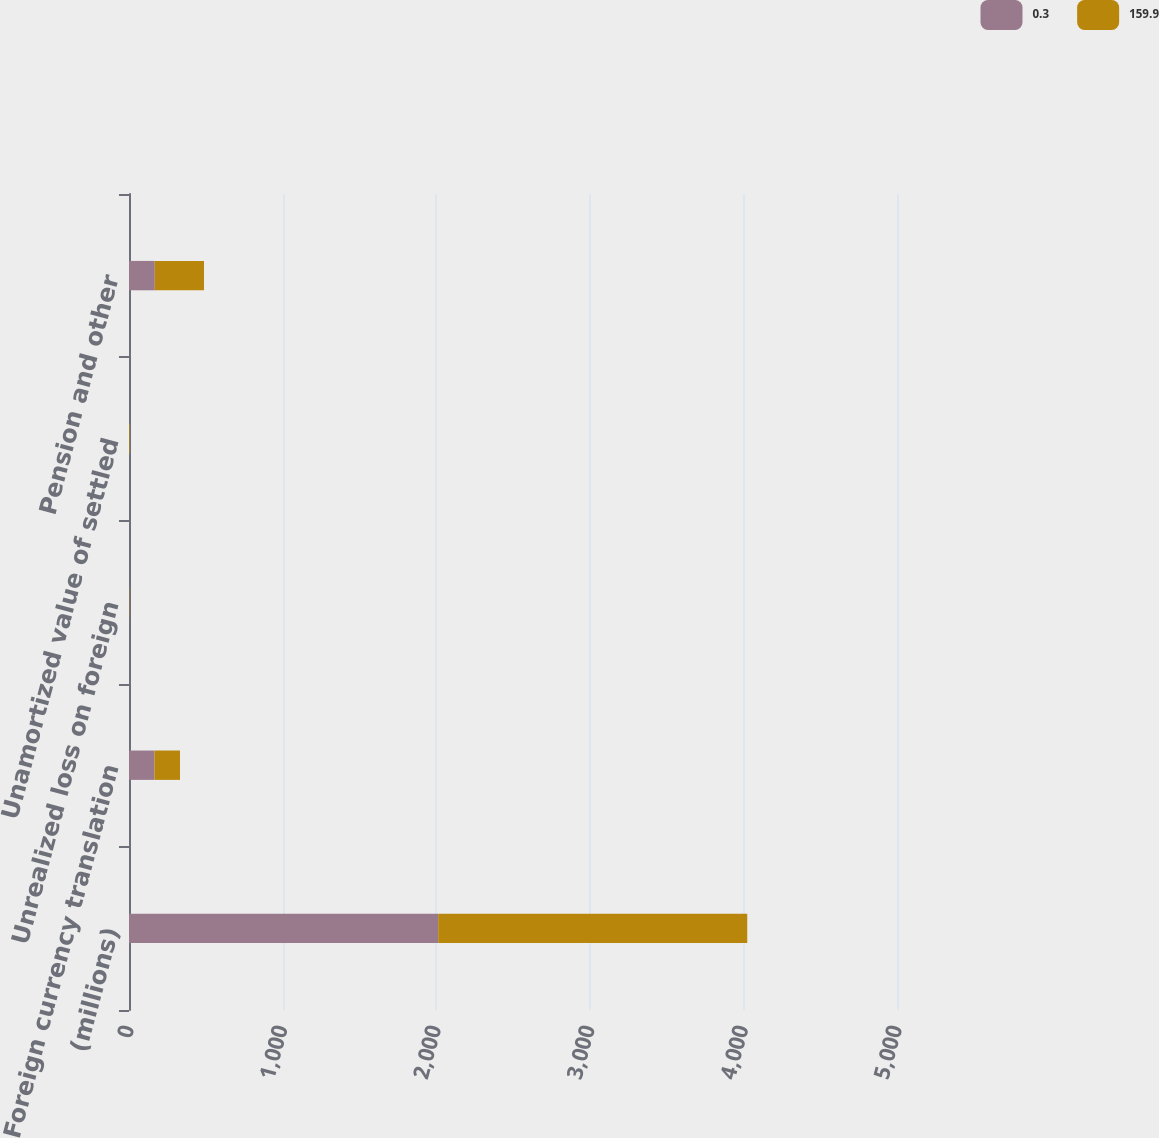<chart> <loc_0><loc_0><loc_500><loc_500><stacked_bar_chart><ecel><fcel>(millions)<fcel>Foreign currency translation<fcel>Unrealized loss on foreign<fcel>Unamortized value of settled<fcel>Pension and other<nl><fcel>0.3<fcel>2013<fcel>165.7<fcel>0.3<fcel>2<fcel>167.7<nl><fcel>159.9<fcel>2012<fcel>166.3<fcel>1.6<fcel>4.1<fcel>320.5<nl></chart> 